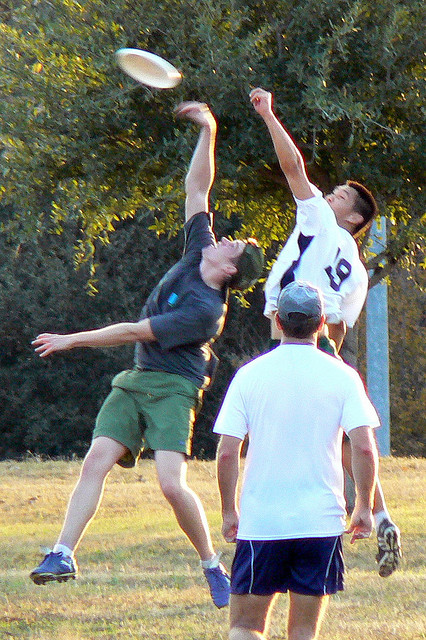Please transcribe the text in this image. 9 